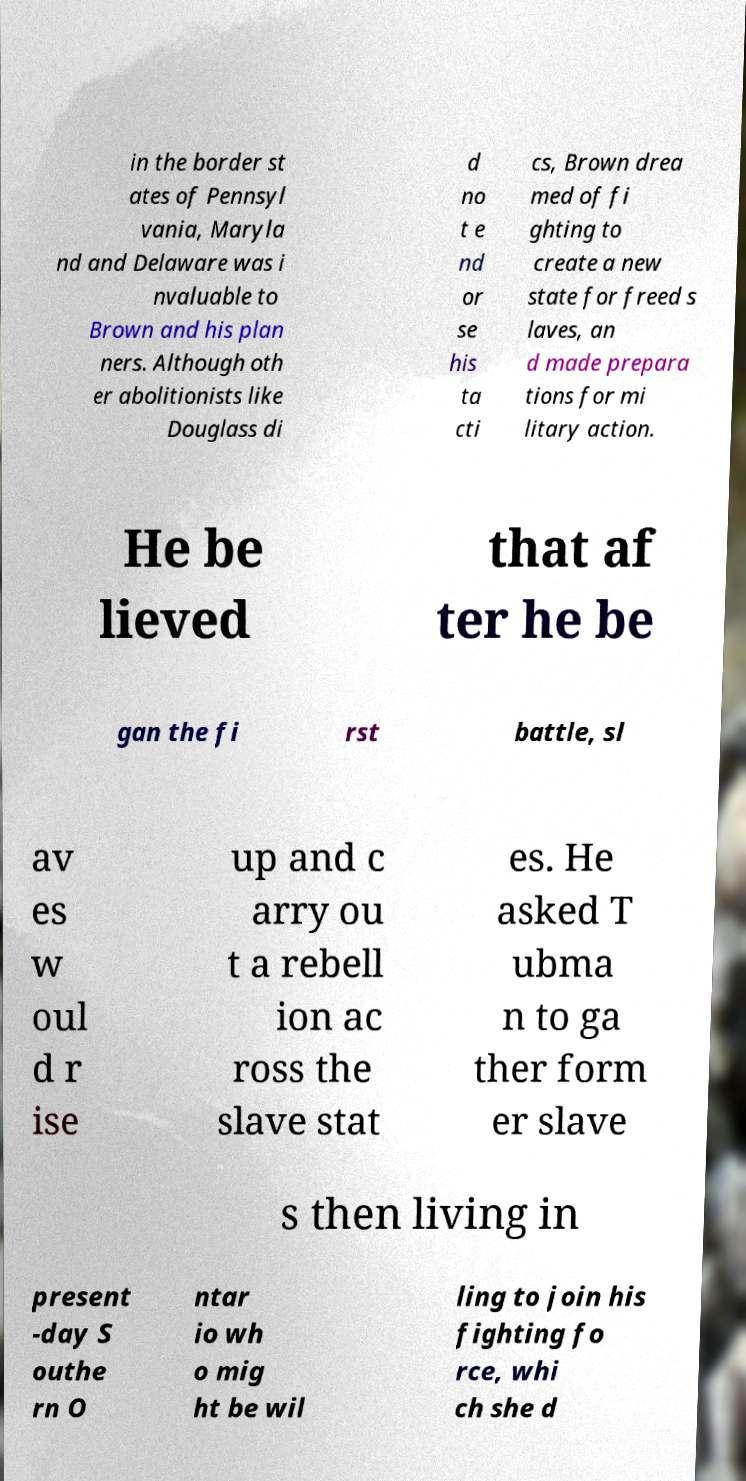What messages or text are displayed in this image? I need them in a readable, typed format. in the border st ates of Pennsyl vania, Maryla nd and Delaware was i nvaluable to Brown and his plan ners. Although oth er abolitionists like Douglass di d no t e nd or se his ta cti cs, Brown drea med of fi ghting to create a new state for freed s laves, an d made prepara tions for mi litary action. He be lieved that af ter he be gan the fi rst battle, sl av es w oul d r ise up and c arry ou t a rebell ion ac ross the slave stat es. He asked T ubma n to ga ther form er slave s then living in present -day S outhe rn O ntar io wh o mig ht be wil ling to join his fighting fo rce, whi ch she d 